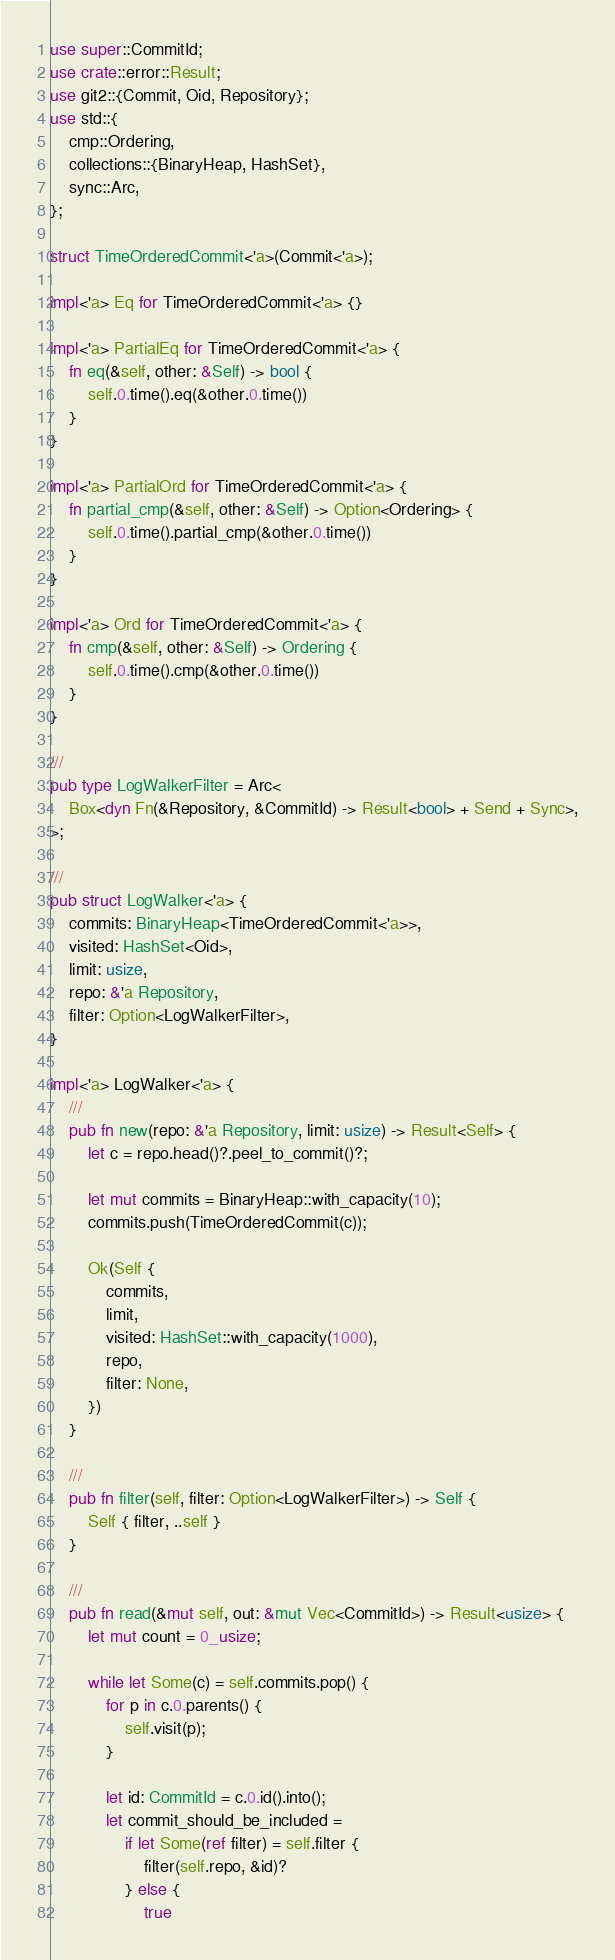Convert code to text. <code><loc_0><loc_0><loc_500><loc_500><_Rust_>use super::CommitId;
use crate::error::Result;
use git2::{Commit, Oid, Repository};
use std::{
	cmp::Ordering,
	collections::{BinaryHeap, HashSet},
	sync::Arc,
};

struct TimeOrderedCommit<'a>(Commit<'a>);

impl<'a> Eq for TimeOrderedCommit<'a> {}

impl<'a> PartialEq for TimeOrderedCommit<'a> {
	fn eq(&self, other: &Self) -> bool {
		self.0.time().eq(&other.0.time())
	}
}

impl<'a> PartialOrd for TimeOrderedCommit<'a> {
	fn partial_cmp(&self, other: &Self) -> Option<Ordering> {
		self.0.time().partial_cmp(&other.0.time())
	}
}

impl<'a> Ord for TimeOrderedCommit<'a> {
	fn cmp(&self, other: &Self) -> Ordering {
		self.0.time().cmp(&other.0.time())
	}
}

///
pub type LogWalkerFilter = Arc<
	Box<dyn Fn(&Repository, &CommitId) -> Result<bool> + Send + Sync>,
>;

///
pub struct LogWalker<'a> {
	commits: BinaryHeap<TimeOrderedCommit<'a>>,
	visited: HashSet<Oid>,
	limit: usize,
	repo: &'a Repository,
	filter: Option<LogWalkerFilter>,
}

impl<'a> LogWalker<'a> {
	///
	pub fn new(repo: &'a Repository, limit: usize) -> Result<Self> {
		let c = repo.head()?.peel_to_commit()?;

		let mut commits = BinaryHeap::with_capacity(10);
		commits.push(TimeOrderedCommit(c));

		Ok(Self {
			commits,
			limit,
			visited: HashSet::with_capacity(1000),
			repo,
			filter: None,
		})
	}

	///
	pub fn filter(self, filter: Option<LogWalkerFilter>) -> Self {
		Self { filter, ..self }
	}

	///
	pub fn read(&mut self, out: &mut Vec<CommitId>) -> Result<usize> {
		let mut count = 0_usize;

		while let Some(c) = self.commits.pop() {
			for p in c.0.parents() {
				self.visit(p);
			}

			let id: CommitId = c.0.id().into();
			let commit_should_be_included =
				if let Some(ref filter) = self.filter {
					filter(self.repo, &id)?
				} else {
					true</code> 